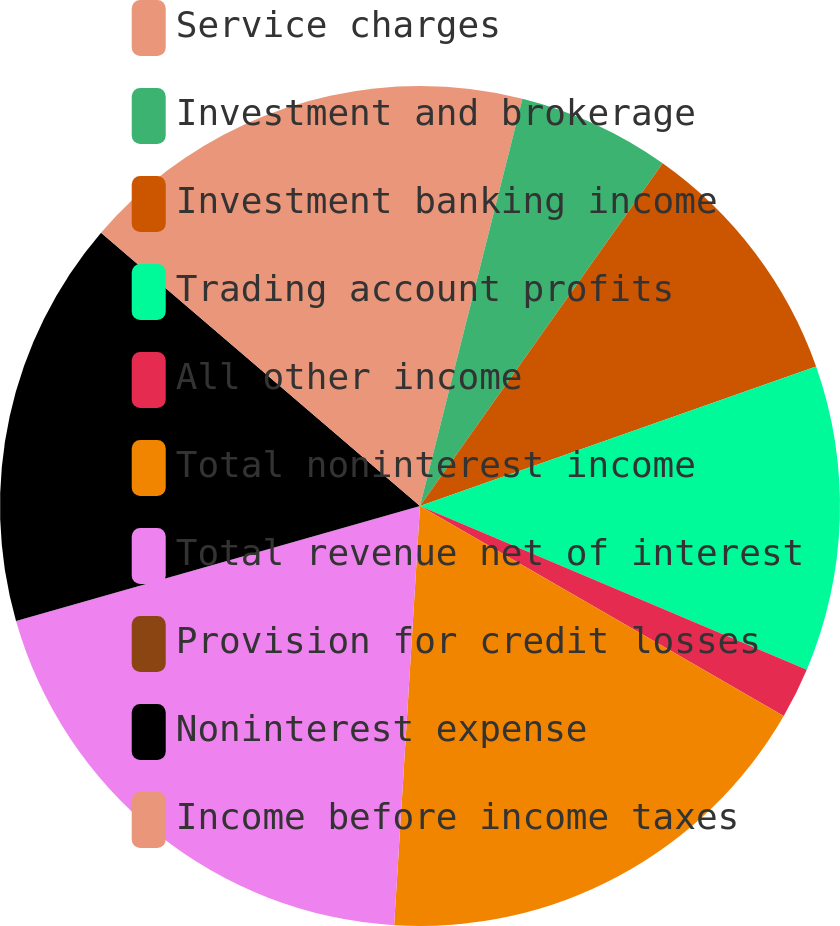Convert chart. <chart><loc_0><loc_0><loc_500><loc_500><pie_chart><fcel>Service charges<fcel>Investment and brokerage<fcel>Investment banking income<fcel>Trading account profits<fcel>All other income<fcel>Total noninterest income<fcel>Total revenue net of interest<fcel>Provision for credit losses<fcel>Noninterest expense<fcel>Income before income taxes<nl><fcel>3.92%<fcel>5.88%<fcel>9.8%<fcel>11.76%<fcel>1.96%<fcel>17.64%<fcel>19.6%<fcel>0.0%<fcel>15.68%<fcel>13.72%<nl></chart> 